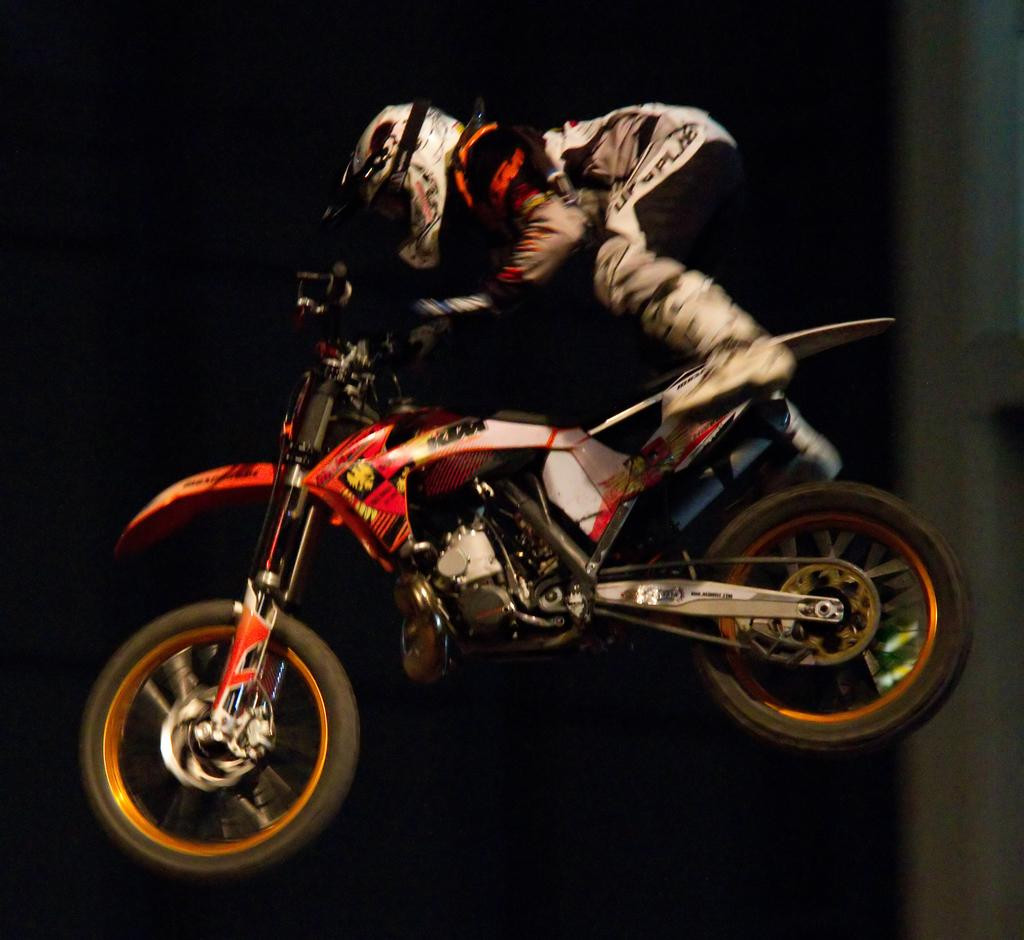What is the main object in the image? There is a bike in the image. Is there anyone on the bike? Yes, a person is on the bike. What safety gear is the person wearing? The person is wearing a helmet. How is the bike positioned in the image? The bike is in the air. What type of knowledge is the person on the bike trying to acquire in the image? There is no indication in the image that the person is trying to acquire any knowledge. 